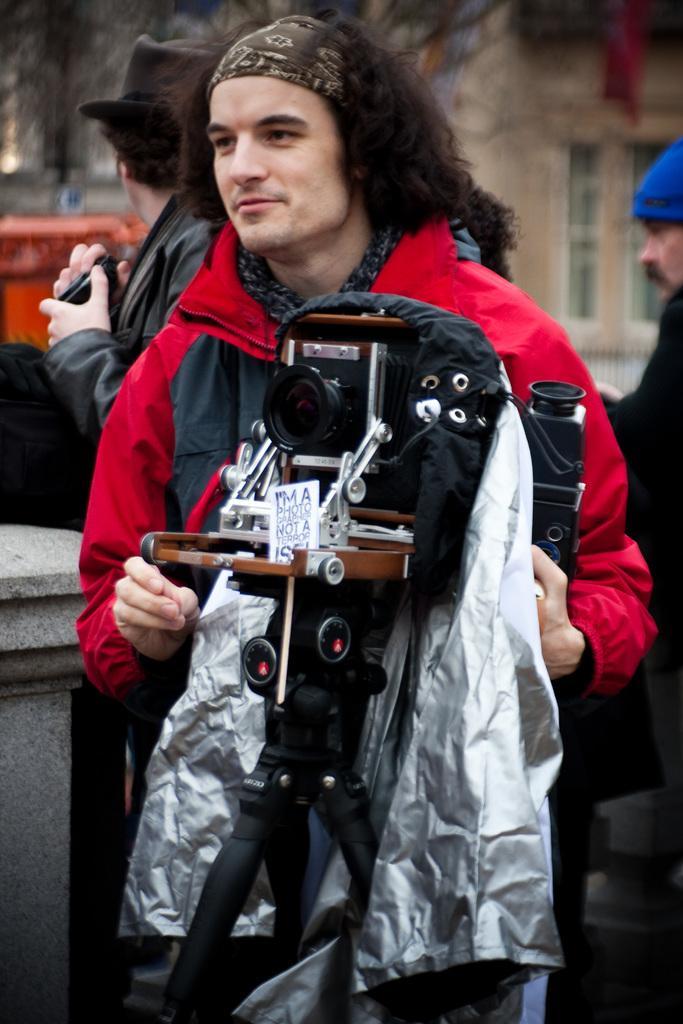Can you describe this image briefly? In this image, we can see persons wearing clothes. There is a camera in the middle of the image. In the background, image is blurred. 